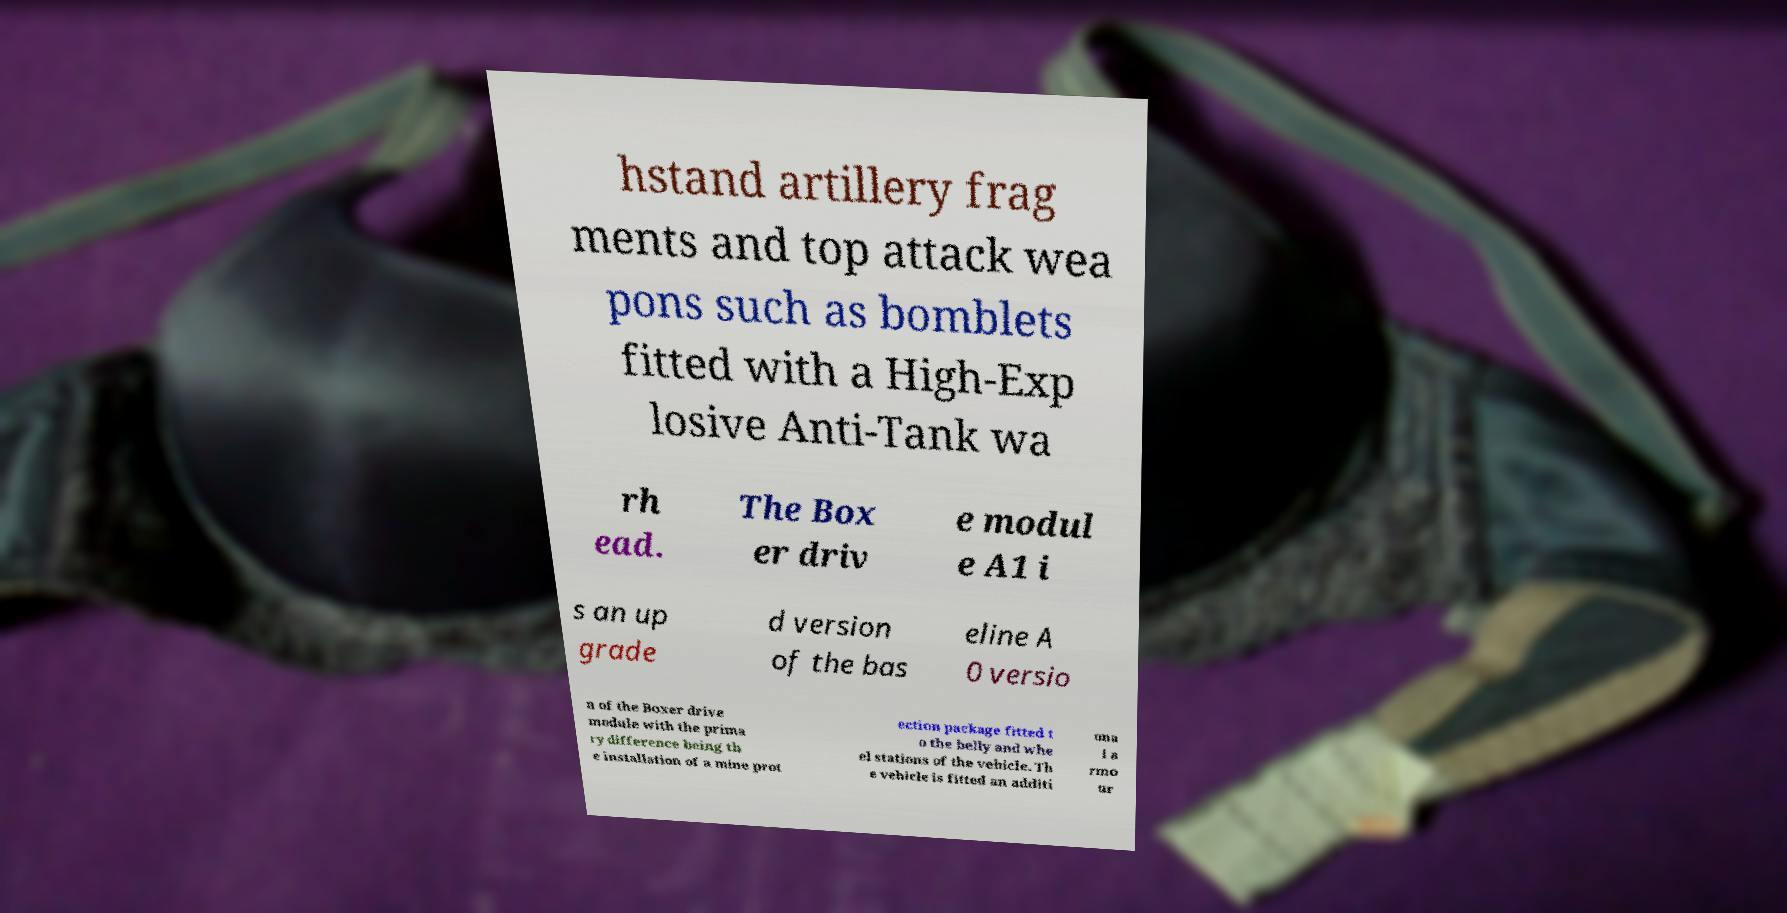I need the written content from this picture converted into text. Can you do that? hstand artillery frag ments and top attack wea pons such as bomblets fitted with a High-Exp losive Anti-Tank wa rh ead. The Box er driv e modul e A1 i s an up grade d version of the bas eline A 0 versio n of the Boxer drive module with the prima ry difference being th e installation of a mine prot ection package fitted t o the belly and whe el stations of the vehicle. Th e vehicle is fitted an additi ona l a rmo ur 